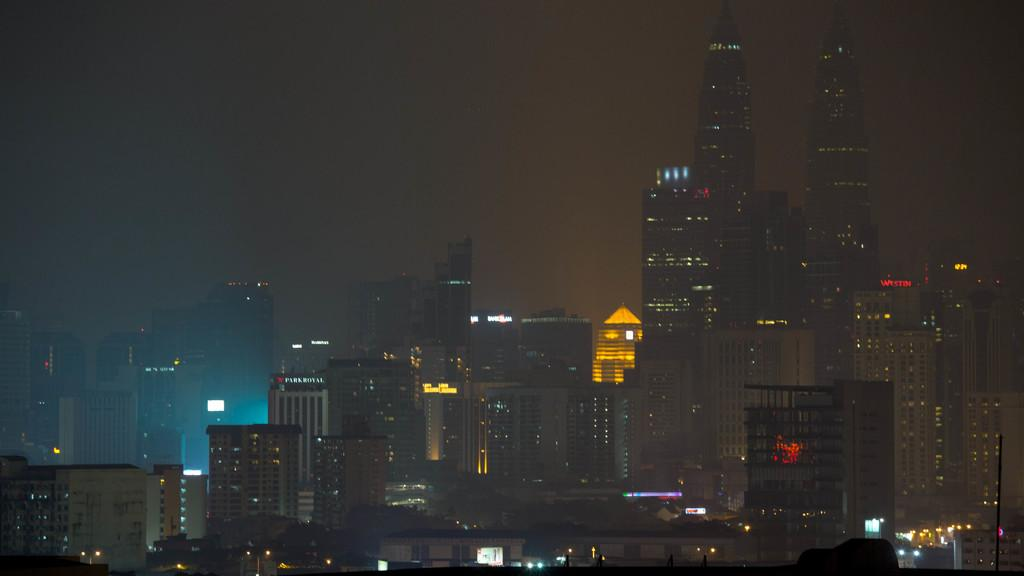What type of structures are present in the image? There are buildings and skyscrapers in the image. What feature do the buildings and skyscrapers have? The buildings and skyscrapers have lights. What can be seen in the background of the image? The sky is visible in the background of the image. What type of silver current can be seen flowing through the mask in the image? There is no silver current or mask present in the image; it features buildings and skyscrapers with lights and a visible sky in the background. 